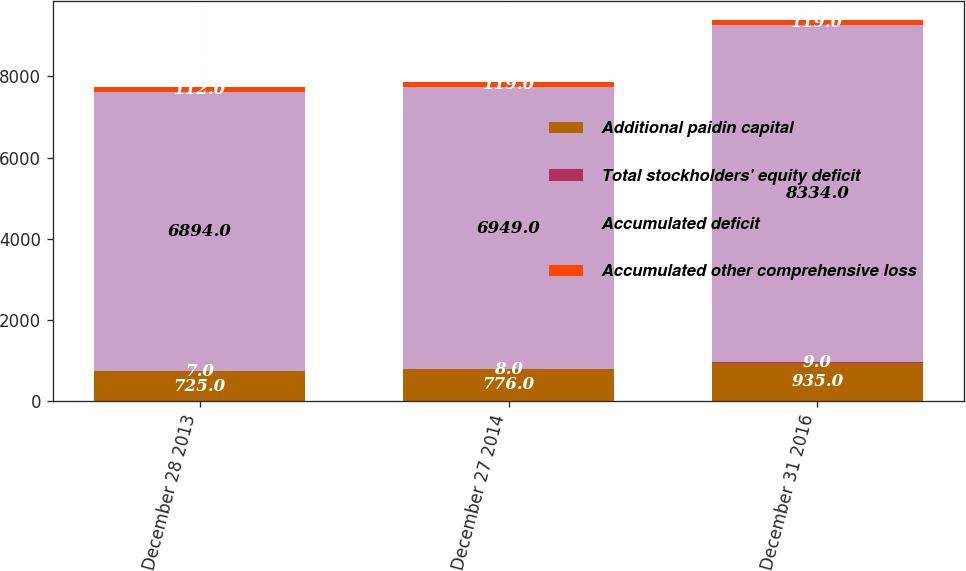<chart> <loc_0><loc_0><loc_500><loc_500><stacked_bar_chart><ecel><fcel>December 28 2013<fcel>December 27 2014<fcel>December 31 2016<nl><fcel>Additional paidin capital<fcel>725<fcel>776<fcel>935<nl><fcel>Total stockholders' equity deficit<fcel>7<fcel>8<fcel>9<nl><fcel>Accumulated deficit<fcel>6894<fcel>6949<fcel>8334<nl><fcel>Accumulated other comprehensive loss<fcel>112<fcel>119<fcel>119<nl></chart> 